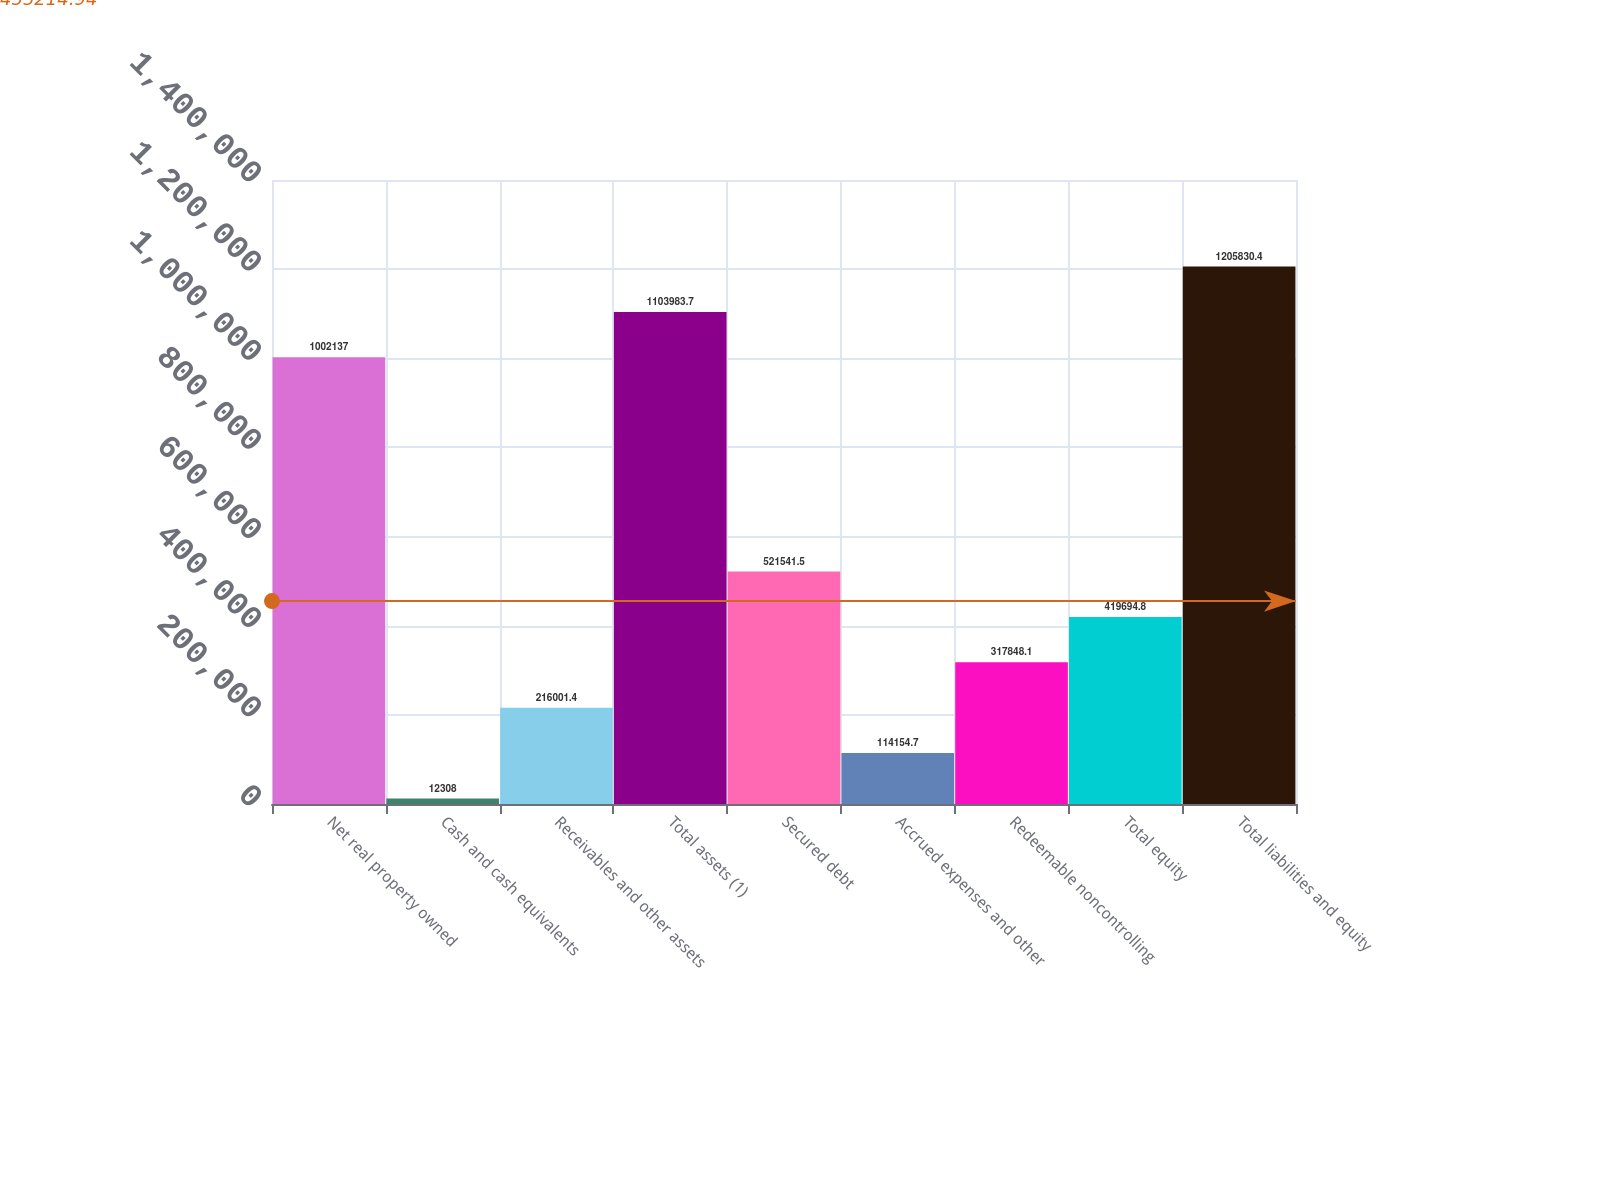<chart> <loc_0><loc_0><loc_500><loc_500><bar_chart><fcel>Net real property owned<fcel>Cash and cash equivalents<fcel>Receivables and other assets<fcel>Total assets (1)<fcel>Secured debt<fcel>Accrued expenses and other<fcel>Redeemable noncontrolling<fcel>Total equity<fcel>Total liabilities and equity<nl><fcel>1.00214e+06<fcel>12308<fcel>216001<fcel>1.10398e+06<fcel>521542<fcel>114155<fcel>317848<fcel>419695<fcel>1.20583e+06<nl></chart> 